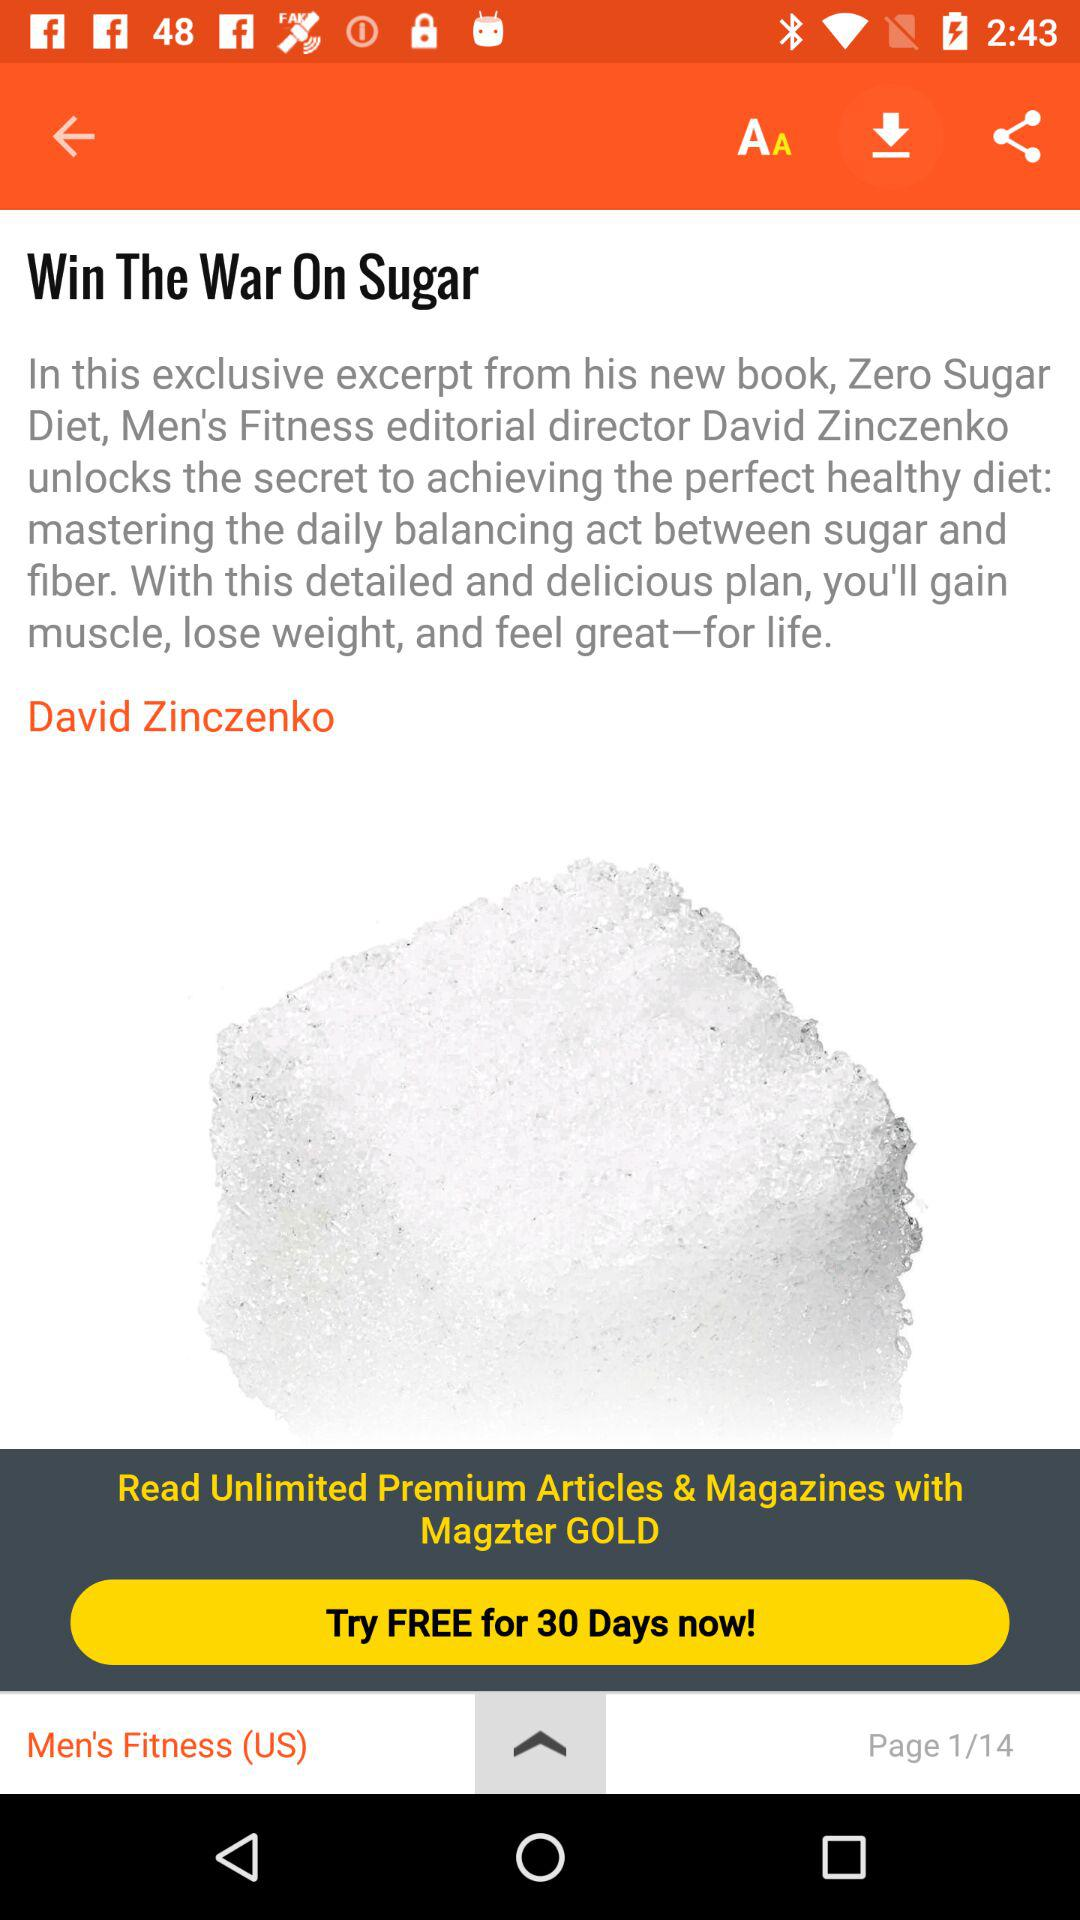How many pages are there in the article?
Answer the question using a single word or phrase. 14 